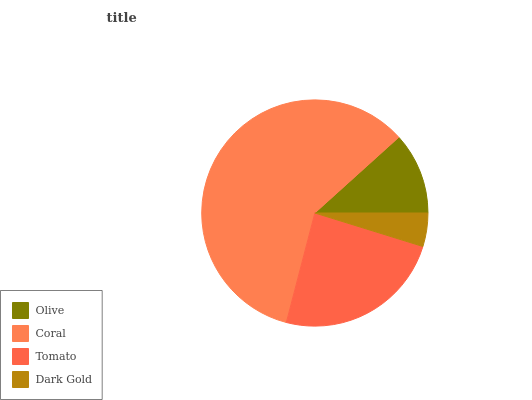Is Dark Gold the minimum?
Answer yes or no. Yes. Is Coral the maximum?
Answer yes or no. Yes. Is Tomato the minimum?
Answer yes or no. No. Is Tomato the maximum?
Answer yes or no. No. Is Coral greater than Tomato?
Answer yes or no. Yes. Is Tomato less than Coral?
Answer yes or no. Yes. Is Tomato greater than Coral?
Answer yes or no. No. Is Coral less than Tomato?
Answer yes or no. No. Is Tomato the high median?
Answer yes or no. Yes. Is Olive the low median?
Answer yes or no. Yes. Is Coral the high median?
Answer yes or no. No. Is Tomato the low median?
Answer yes or no. No. 